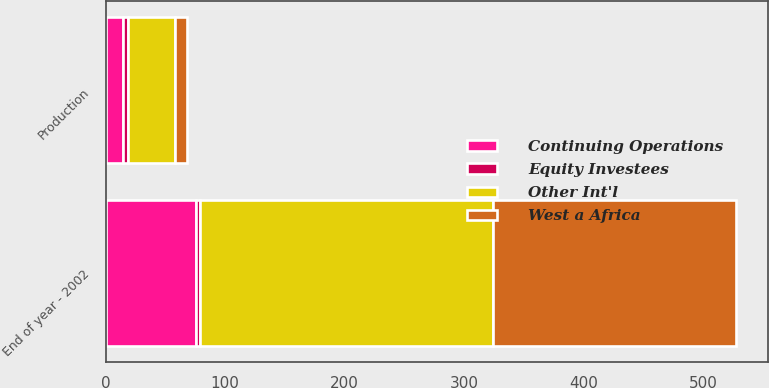<chart> <loc_0><loc_0><loc_500><loc_500><stacked_bar_chart><ecel><fcel>End of year - 2002<fcel>Production<nl><fcel>Other Int'l<fcel>245<fcel>39<nl><fcel>Continuing Operations<fcel>76<fcel>15<nl><fcel>West a Africa<fcel>203<fcel>10<nl><fcel>Equity Investees<fcel>3<fcel>4<nl></chart> 